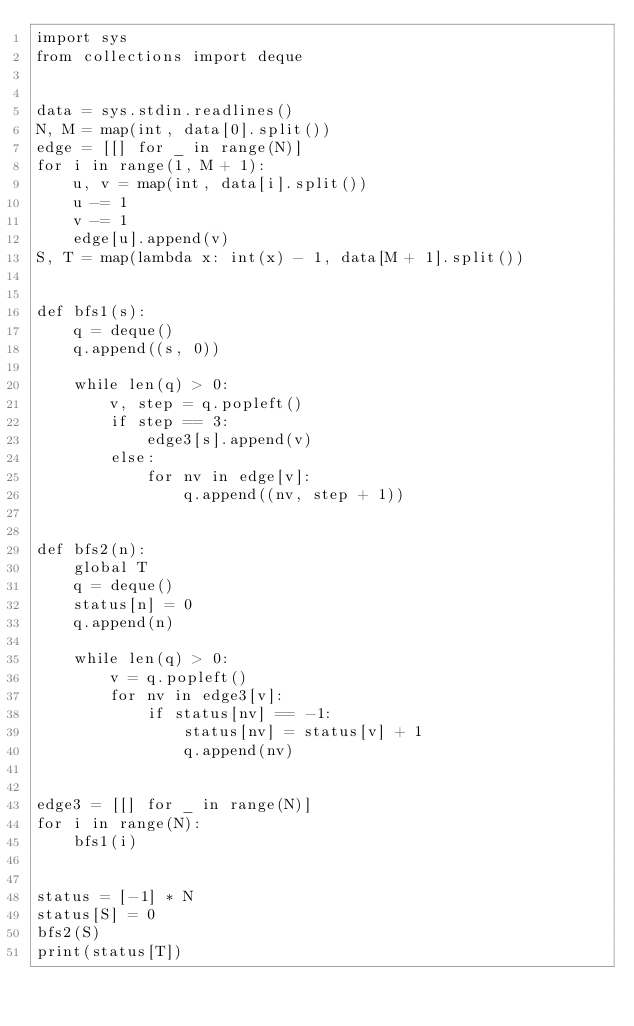<code> <loc_0><loc_0><loc_500><loc_500><_Python_>import sys
from collections import deque


data = sys.stdin.readlines()
N, M = map(int, data[0].split())
edge = [[] for _ in range(N)]
for i in range(1, M + 1):
    u, v = map(int, data[i].split())
    u -= 1
    v -= 1
    edge[u].append(v)
S, T = map(lambda x: int(x) - 1, data[M + 1].split())


def bfs1(s):
    q = deque()
    q.append((s, 0))

    while len(q) > 0:
        v, step = q.popleft()
        if step == 3:
            edge3[s].append(v)
        else:
            for nv in edge[v]:
                q.append((nv, step + 1))


def bfs2(n):
    global T
    q = deque()
    status[n] = 0
    q.append(n)

    while len(q) > 0:
        v = q.popleft()
        for nv in edge3[v]:
            if status[nv] == -1:
                status[nv] = status[v] + 1
                q.append(nv)


edge3 = [[] for _ in range(N)]
for i in range(N):
    bfs1(i)


status = [-1] * N
status[S] = 0
bfs2(S)
print(status[T])
</code> 